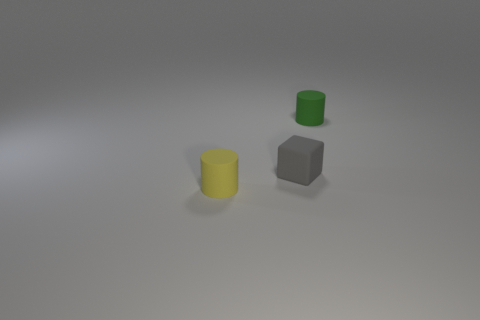Subtract 2 cylinders. How many cylinders are left? 0 Add 2 yellow rubber things. How many objects exist? 5 Subtract all green objects. Subtract all tiny cylinders. How many objects are left? 0 Add 1 tiny yellow matte objects. How many tiny yellow matte objects are left? 2 Add 3 small green objects. How many small green objects exist? 4 Subtract 1 yellow cylinders. How many objects are left? 2 Subtract all cylinders. How many objects are left? 1 Subtract all gray cylinders. Subtract all blue blocks. How many cylinders are left? 2 Subtract all cyan balls. How many green cylinders are left? 1 